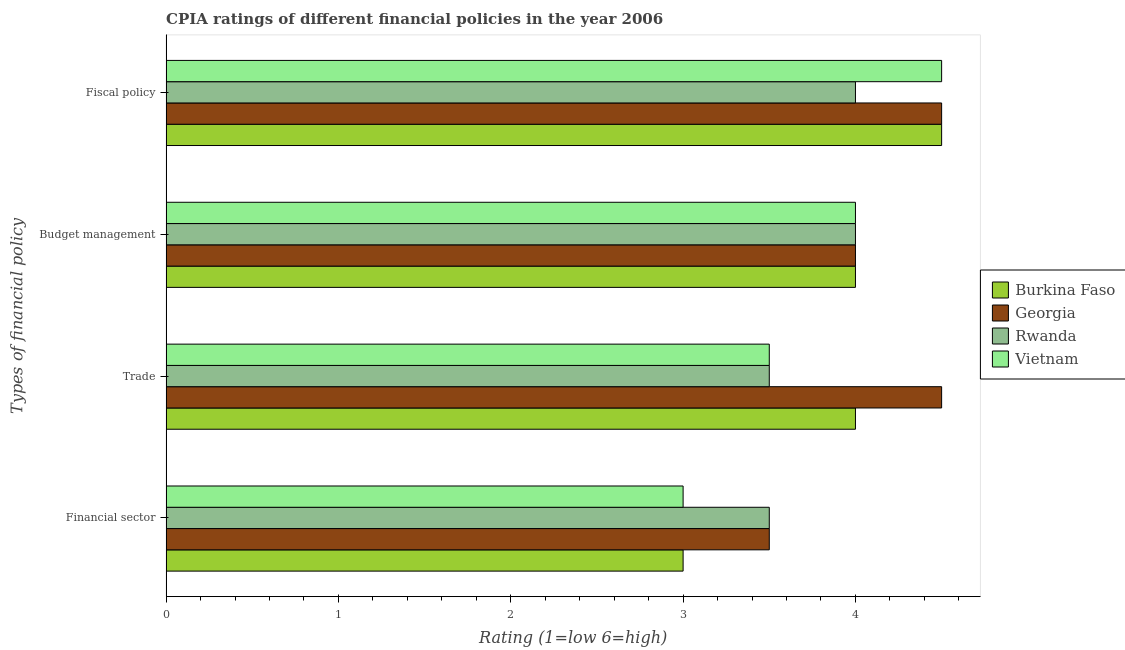How many different coloured bars are there?
Offer a very short reply. 4. Are the number of bars on each tick of the Y-axis equal?
Provide a short and direct response. Yes. How many bars are there on the 3rd tick from the bottom?
Your answer should be very brief. 4. What is the label of the 2nd group of bars from the top?
Offer a terse response. Budget management. In which country was the cpia rating of financial sector maximum?
Your answer should be very brief. Georgia. In which country was the cpia rating of budget management minimum?
Make the answer very short. Burkina Faso. What is the total cpia rating of fiscal policy in the graph?
Your answer should be compact. 17.5. What is the difference between the cpia rating of budget management in Vietnam and that in Rwanda?
Your answer should be compact. 0. What is the average cpia rating of budget management per country?
Make the answer very short. 4. In how many countries, is the cpia rating of budget management greater than 4.2 ?
Your response must be concise. 0. What is the ratio of the cpia rating of financial sector in Rwanda to that in Burkina Faso?
Provide a short and direct response. 1.17. Is the cpia rating of fiscal policy in Rwanda less than that in Vietnam?
Offer a terse response. Yes. What is the difference between the highest and the lowest cpia rating of trade?
Give a very brief answer. 1. Is it the case that in every country, the sum of the cpia rating of trade and cpia rating of fiscal policy is greater than the sum of cpia rating of budget management and cpia rating of financial sector?
Your answer should be very brief. No. What does the 1st bar from the top in Financial sector represents?
Your response must be concise. Vietnam. What does the 1st bar from the bottom in Trade represents?
Offer a very short reply. Burkina Faso. Is it the case that in every country, the sum of the cpia rating of financial sector and cpia rating of trade is greater than the cpia rating of budget management?
Your response must be concise. Yes. How many bars are there?
Offer a very short reply. 16. Are all the bars in the graph horizontal?
Ensure brevity in your answer.  Yes. Are the values on the major ticks of X-axis written in scientific E-notation?
Give a very brief answer. No. Where does the legend appear in the graph?
Give a very brief answer. Center right. What is the title of the graph?
Keep it short and to the point. CPIA ratings of different financial policies in the year 2006. What is the label or title of the X-axis?
Your answer should be compact. Rating (1=low 6=high). What is the label or title of the Y-axis?
Make the answer very short. Types of financial policy. What is the Rating (1=low 6=high) of Rwanda in Financial sector?
Make the answer very short. 3.5. What is the Rating (1=low 6=high) of Rwanda in Trade?
Provide a short and direct response. 3.5. What is the Rating (1=low 6=high) in Vietnam in Trade?
Your answer should be very brief. 3.5. What is the Rating (1=low 6=high) in Vietnam in Budget management?
Offer a terse response. 4. What is the Rating (1=low 6=high) in Rwanda in Fiscal policy?
Offer a terse response. 4. Across all Types of financial policy, what is the maximum Rating (1=low 6=high) of Burkina Faso?
Give a very brief answer. 4.5. Across all Types of financial policy, what is the maximum Rating (1=low 6=high) of Georgia?
Offer a very short reply. 4.5. Across all Types of financial policy, what is the minimum Rating (1=low 6=high) of Georgia?
Keep it short and to the point. 3.5. What is the total Rating (1=low 6=high) of Burkina Faso in the graph?
Provide a succinct answer. 15.5. What is the total Rating (1=low 6=high) in Georgia in the graph?
Offer a terse response. 16.5. What is the total Rating (1=low 6=high) of Rwanda in the graph?
Offer a terse response. 15. What is the total Rating (1=low 6=high) in Vietnam in the graph?
Give a very brief answer. 15. What is the difference between the Rating (1=low 6=high) in Burkina Faso in Financial sector and that in Trade?
Your response must be concise. -1. What is the difference between the Rating (1=low 6=high) in Rwanda in Financial sector and that in Trade?
Offer a terse response. 0. What is the difference between the Rating (1=low 6=high) in Burkina Faso in Financial sector and that in Budget management?
Your answer should be compact. -1. What is the difference between the Rating (1=low 6=high) of Georgia in Financial sector and that in Budget management?
Give a very brief answer. -0.5. What is the difference between the Rating (1=low 6=high) of Rwanda in Financial sector and that in Budget management?
Give a very brief answer. -0.5. What is the difference between the Rating (1=low 6=high) of Georgia in Financial sector and that in Fiscal policy?
Offer a terse response. -1. What is the difference between the Rating (1=low 6=high) of Burkina Faso in Trade and that in Budget management?
Offer a terse response. 0. What is the difference between the Rating (1=low 6=high) in Georgia in Trade and that in Budget management?
Your answer should be compact. 0.5. What is the difference between the Rating (1=low 6=high) in Vietnam in Trade and that in Budget management?
Ensure brevity in your answer.  -0.5. What is the difference between the Rating (1=low 6=high) in Burkina Faso in Trade and that in Fiscal policy?
Your answer should be compact. -0.5. What is the difference between the Rating (1=low 6=high) in Georgia in Trade and that in Fiscal policy?
Keep it short and to the point. 0. What is the difference between the Rating (1=low 6=high) in Rwanda in Trade and that in Fiscal policy?
Your response must be concise. -0.5. What is the difference between the Rating (1=low 6=high) in Vietnam in Trade and that in Fiscal policy?
Ensure brevity in your answer.  -1. What is the difference between the Rating (1=low 6=high) of Rwanda in Budget management and that in Fiscal policy?
Keep it short and to the point. 0. What is the difference between the Rating (1=low 6=high) of Burkina Faso in Financial sector and the Rating (1=low 6=high) of Georgia in Trade?
Offer a terse response. -1.5. What is the difference between the Rating (1=low 6=high) of Burkina Faso in Financial sector and the Rating (1=low 6=high) of Rwanda in Trade?
Your answer should be compact. -0.5. What is the difference between the Rating (1=low 6=high) in Burkina Faso in Financial sector and the Rating (1=low 6=high) in Vietnam in Trade?
Offer a very short reply. -0.5. What is the difference between the Rating (1=low 6=high) in Georgia in Financial sector and the Rating (1=low 6=high) in Vietnam in Trade?
Your response must be concise. 0. What is the difference between the Rating (1=low 6=high) of Burkina Faso in Financial sector and the Rating (1=low 6=high) of Rwanda in Budget management?
Make the answer very short. -1. What is the difference between the Rating (1=low 6=high) in Burkina Faso in Financial sector and the Rating (1=low 6=high) in Vietnam in Budget management?
Your response must be concise. -1. What is the difference between the Rating (1=low 6=high) of Rwanda in Financial sector and the Rating (1=low 6=high) of Vietnam in Budget management?
Give a very brief answer. -0.5. What is the difference between the Rating (1=low 6=high) of Burkina Faso in Financial sector and the Rating (1=low 6=high) of Vietnam in Fiscal policy?
Make the answer very short. -1.5. What is the difference between the Rating (1=low 6=high) in Georgia in Financial sector and the Rating (1=low 6=high) in Vietnam in Fiscal policy?
Keep it short and to the point. -1. What is the difference between the Rating (1=low 6=high) in Burkina Faso in Trade and the Rating (1=low 6=high) in Vietnam in Budget management?
Offer a very short reply. 0. What is the difference between the Rating (1=low 6=high) of Georgia in Trade and the Rating (1=low 6=high) of Rwanda in Budget management?
Your answer should be very brief. 0.5. What is the difference between the Rating (1=low 6=high) of Burkina Faso in Trade and the Rating (1=low 6=high) of Rwanda in Fiscal policy?
Provide a short and direct response. 0. What is the difference between the Rating (1=low 6=high) in Burkina Faso in Trade and the Rating (1=low 6=high) in Vietnam in Fiscal policy?
Offer a terse response. -0.5. What is the difference between the Rating (1=low 6=high) in Georgia in Trade and the Rating (1=low 6=high) in Rwanda in Fiscal policy?
Offer a very short reply. 0.5. What is the difference between the Rating (1=low 6=high) of Georgia in Budget management and the Rating (1=low 6=high) of Vietnam in Fiscal policy?
Offer a very short reply. -0.5. What is the average Rating (1=low 6=high) in Burkina Faso per Types of financial policy?
Provide a succinct answer. 3.88. What is the average Rating (1=low 6=high) of Georgia per Types of financial policy?
Your answer should be very brief. 4.12. What is the average Rating (1=low 6=high) in Rwanda per Types of financial policy?
Your answer should be compact. 3.75. What is the average Rating (1=low 6=high) of Vietnam per Types of financial policy?
Offer a terse response. 3.75. What is the difference between the Rating (1=low 6=high) of Burkina Faso and Rating (1=low 6=high) of Georgia in Financial sector?
Your answer should be very brief. -0.5. What is the difference between the Rating (1=low 6=high) of Burkina Faso and Rating (1=low 6=high) of Rwanda in Financial sector?
Your response must be concise. -0.5. What is the difference between the Rating (1=low 6=high) in Burkina Faso and Rating (1=low 6=high) in Vietnam in Financial sector?
Make the answer very short. 0. What is the difference between the Rating (1=low 6=high) in Georgia and Rating (1=low 6=high) in Vietnam in Financial sector?
Offer a very short reply. 0.5. What is the difference between the Rating (1=low 6=high) of Burkina Faso and Rating (1=low 6=high) of Georgia in Trade?
Provide a short and direct response. -0.5. What is the difference between the Rating (1=low 6=high) in Burkina Faso and Rating (1=low 6=high) in Rwanda in Trade?
Provide a succinct answer. 0.5. What is the difference between the Rating (1=low 6=high) of Georgia and Rating (1=low 6=high) of Rwanda in Trade?
Provide a short and direct response. 1. What is the difference between the Rating (1=low 6=high) in Rwanda and Rating (1=low 6=high) in Vietnam in Trade?
Provide a short and direct response. 0. What is the difference between the Rating (1=low 6=high) of Burkina Faso and Rating (1=low 6=high) of Georgia in Budget management?
Provide a short and direct response. 0. What is the difference between the Rating (1=low 6=high) in Burkina Faso and Rating (1=low 6=high) in Vietnam in Budget management?
Provide a succinct answer. 0. What is the difference between the Rating (1=low 6=high) in Rwanda and Rating (1=low 6=high) in Vietnam in Budget management?
Give a very brief answer. 0. What is the difference between the Rating (1=low 6=high) of Rwanda and Rating (1=low 6=high) of Vietnam in Fiscal policy?
Make the answer very short. -0.5. What is the ratio of the Rating (1=low 6=high) of Burkina Faso in Financial sector to that in Trade?
Offer a terse response. 0.75. What is the ratio of the Rating (1=low 6=high) in Vietnam in Financial sector to that in Trade?
Your answer should be very brief. 0.86. What is the ratio of the Rating (1=low 6=high) of Burkina Faso in Financial sector to that in Fiscal policy?
Provide a short and direct response. 0.67. What is the ratio of the Rating (1=low 6=high) of Rwanda in Financial sector to that in Fiscal policy?
Keep it short and to the point. 0.88. What is the ratio of the Rating (1=low 6=high) of Georgia in Trade to that in Budget management?
Offer a very short reply. 1.12. What is the ratio of the Rating (1=low 6=high) in Georgia in Trade to that in Fiscal policy?
Make the answer very short. 1. What is the ratio of the Rating (1=low 6=high) of Rwanda in Trade to that in Fiscal policy?
Your answer should be compact. 0.88. What is the ratio of the Rating (1=low 6=high) of Rwanda in Budget management to that in Fiscal policy?
Give a very brief answer. 1. What is the ratio of the Rating (1=low 6=high) of Vietnam in Budget management to that in Fiscal policy?
Offer a terse response. 0.89. What is the difference between the highest and the second highest Rating (1=low 6=high) in Burkina Faso?
Offer a very short reply. 0.5. What is the difference between the highest and the lowest Rating (1=low 6=high) of Georgia?
Provide a short and direct response. 1. What is the difference between the highest and the lowest Rating (1=low 6=high) of Rwanda?
Give a very brief answer. 0.5. 